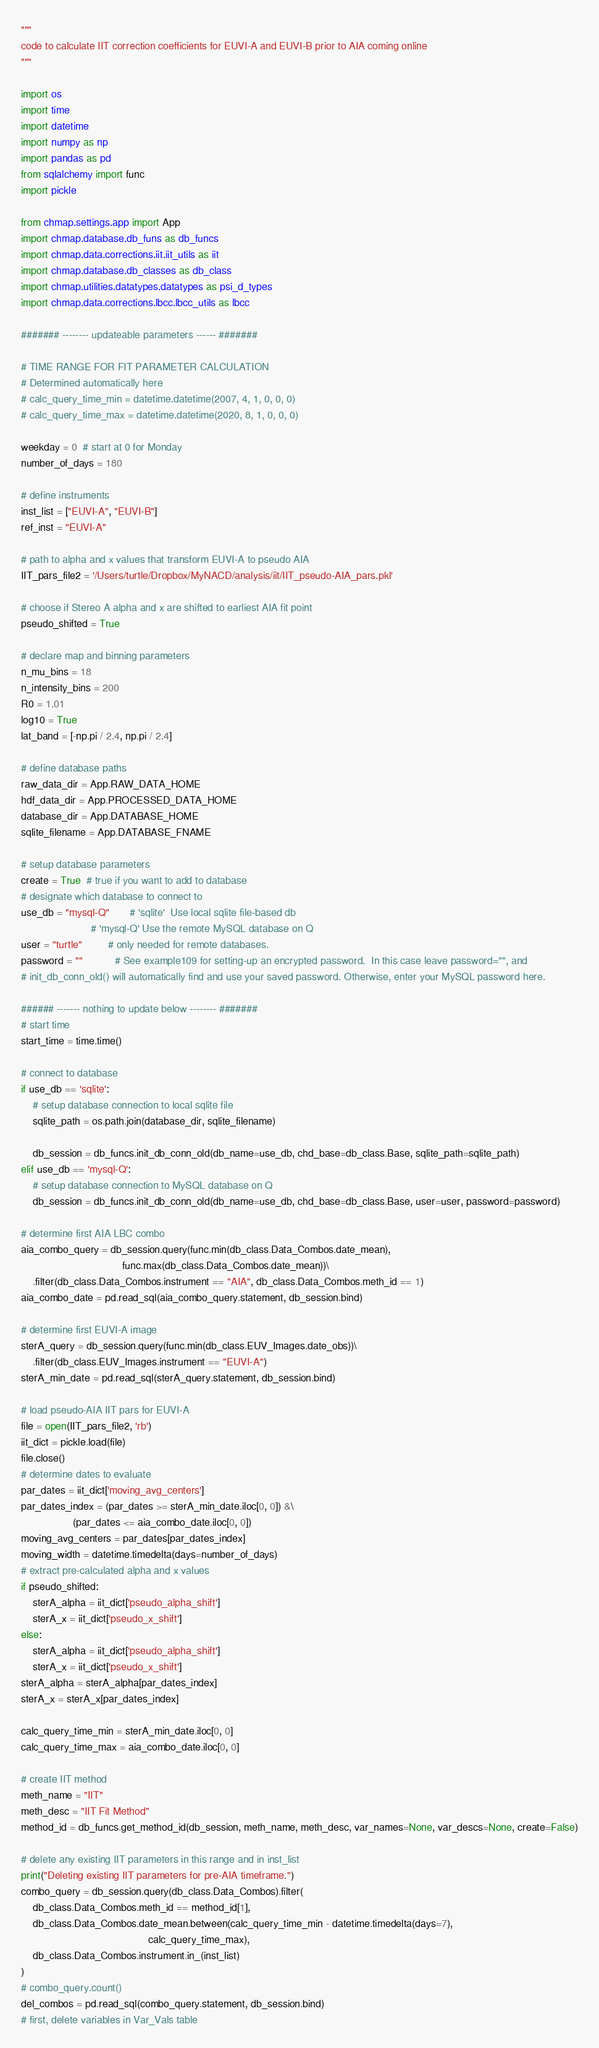Convert code to text. <code><loc_0><loc_0><loc_500><loc_500><_Python_>
"""
code to calculate IIT correction coefficients for EUVI-A and EUVI-B prior to AIA coming online
"""

import os
import time
import datetime
import numpy as np
import pandas as pd
from sqlalchemy import func
import pickle

from chmap.settings.app import App
import chmap.database.db_funs as db_funcs
import chmap.data.corrections.iit.iit_utils as iit
import chmap.database.db_classes as db_class
import chmap.utilities.datatypes.datatypes as psi_d_types
import chmap.data.corrections.lbcc.lbcc_utils as lbcc

####### -------- updateable parameters ------ #######

# TIME RANGE FOR FIT PARAMETER CALCULATION
# Determined automatically here
# calc_query_time_min = datetime.datetime(2007, 4, 1, 0, 0, 0)
# calc_query_time_max = datetime.datetime(2020, 8, 1, 0, 0, 0)

weekday = 0  # start at 0 for Monday
number_of_days = 180

# define instruments
inst_list = ["EUVI-A", "EUVI-B"]
ref_inst = "EUVI-A"

# path to alpha and x values that transform EUVI-A to pseudo AIA
IIT_pars_file2 = '/Users/turtle/Dropbox/MyNACD/analysis/iit/IIT_pseudo-AIA_pars.pkl'

# choose if Stereo A alpha and x are shifted to earliest AIA fit point
pseudo_shifted = True

# declare map and binning parameters
n_mu_bins = 18
n_intensity_bins = 200
R0 = 1.01
log10 = True
lat_band = [-np.pi / 2.4, np.pi / 2.4]

# define database paths
raw_data_dir = App.RAW_DATA_HOME
hdf_data_dir = App.PROCESSED_DATA_HOME
database_dir = App.DATABASE_HOME
sqlite_filename = App.DATABASE_FNAME

# setup database parameters
create = True  # true if you want to add to database
# designate which database to connect to
use_db = "mysql-Q"       # 'sqlite'  Use local sqlite file-based db
                        # 'mysql-Q' Use the remote MySQL database on Q
user = "turtle"         # only needed for remote databases.
password = ""           # See example109 for setting-up an encrypted password.  In this case leave password="", and
# init_db_conn_old() will automatically find and use your saved password. Otherwise, enter your MySQL password here.

###### ------- nothing to update below -------- #######
# start time
start_time = time.time()

# connect to database
if use_db == 'sqlite':
    # setup database connection to local sqlite file
    sqlite_path = os.path.join(database_dir, sqlite_filename)

    db_session = db_funcs.init_db_conn_old(db_name=use_db, chd_base=db_class.Base, sqlite_path=sqlite_path)
elif use_db == 'mysql-Q':
    # setup database connection to MySQL database on Q
    db_session = db_funcs.init_db_conn_old(db_name=use_db, chd_base=db_class.Base, user=user, password=password)

# determine first AIA LBC combo
aia_combo_query = db_session.query(func.min(db_class.Data_Combos.date_mean),
                                   func.max(db_class.Data_Combos.date_mean))\
    .filter(db_class.Data_Combos.instrument == "AIA", db_class.Data_Combos.meth_id == 1)
aia_combo_date = pd.read_sql(aia_combo_query.statement, db_session.bind)

# determine first EUVI-A image
sterA_query = db_session.query(func.min(db_class.EUV_Images.date_obs))\
    .filter(db_class.EUV_Images.instrument == "EUVI-A")
sterA_min_date = pd.read_sql(sterA_query.statement, db_session.bind)

# load pseudo-AIA IIT pars for EUVI-A
file = open(IIT_pars_file2, 'rb')
iit_dict = pickle.load(file)
file.close()
# determine dates to evaluate
par_dates = iit_dict['moving_avg_centers']
par_dates_index = (par_dates >= sterA_min_date.iloc[0, 0]) &\
                  (par_dates <= aia_combo_date.iloc[0, 0])
moving_avg_centers = par_dates[par_dates_index]
moving_width = datetime.timedelta(days=number_of_days)
# extract pre-calculated alpha and x values
if pseudo_shifted:
    sterA_alpha = iit_dict['pseudo_alpha_shift']
    sterA_x = iit_dict['pseudo_x_shift']
else:
    sterA_alpha = iit_dict['pseudo_alpha_shift']
    sterA_x = iit_dict['pseudo_x_shift']
sterA_alpha = sterA_alpha[par_dates_index]
sterA_x = sterA_x[par_dates_index]

calc_query_time_min = sterA_min_date.iloc[0, 0]
calc_query_time_max = aia_combo_date.iloc[0, 0]

# create IIT method
meth_name = "IIT"
meth_desc = "IIT Fit Method"
method_id = db_funcs.get_method_id(db_session, meth_name, meth_desc, var_names=None, var_descs=None, create=False)

# delete any existing IIT parameters in this range and in inst_list
print("Deleting existing IIT parameters for pre-AIA timeframe.")
combo_query = db_session.query(db_class.Data_Combos).filter(
    db_class.Data_Combos.meth_id == method_id[1],
    db_class.Data_Combos.date_mean.between(calc_query_time_min - datetime.timedelta(days=7),
                                            calc_query_time_max),
    db_class.Data_Combos.instrument.in_(inst_list)
)
# combo_query.count()
del_combos = pd.read_sql(combo_query.statement, db_session.bind)
# first, delete variables in Var_Vals table</code> 